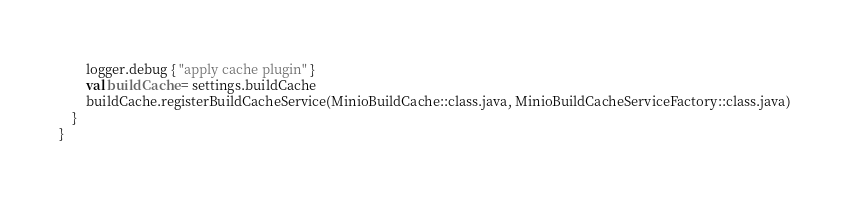Convert code to text. <code><loc_0><loc_0><loc_500><loc_500><_Kotlin_>        logger.debug { "apply cache plugin" }
        val buildCache = settings.buildCache
        buildCache.registerBuildCacheService(MinioBuildCache::class.java, MinioBuildCacheServiceFactory::class.java)
    }
}</code> 